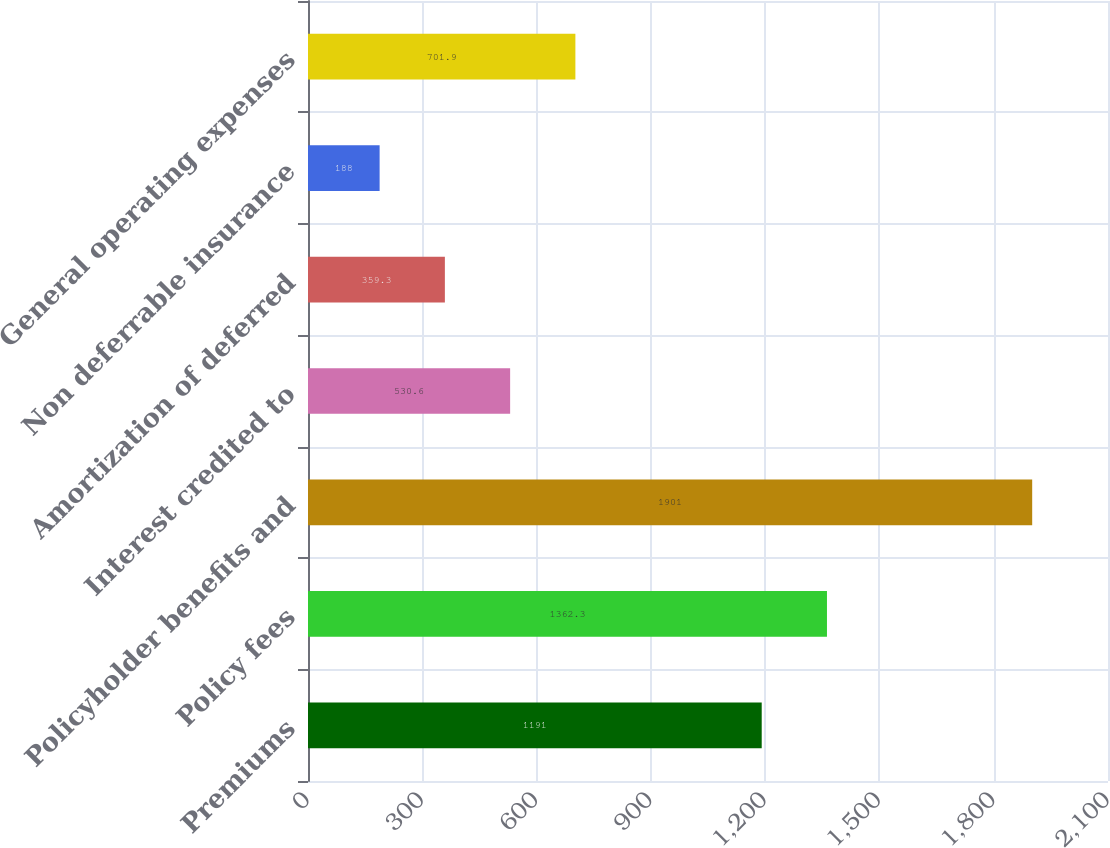Convert chart to OTSL. <chart><loc_0><loc_0><loc_500><loc_500><bar_chart><fcel>Premiums<fcel>Policy fees<fcel>Policyholder benefits and<fcel>Interest credited to<fcel>Amortization of deferred<fcel>Non deferrable insurance<fcel>General operating expenses<nl><fcel>1191<fcel>1362.3<fcel>1901<fcel>530.6<fcel>359.3<fcel>188<fcel>701.9<nl></chart> 